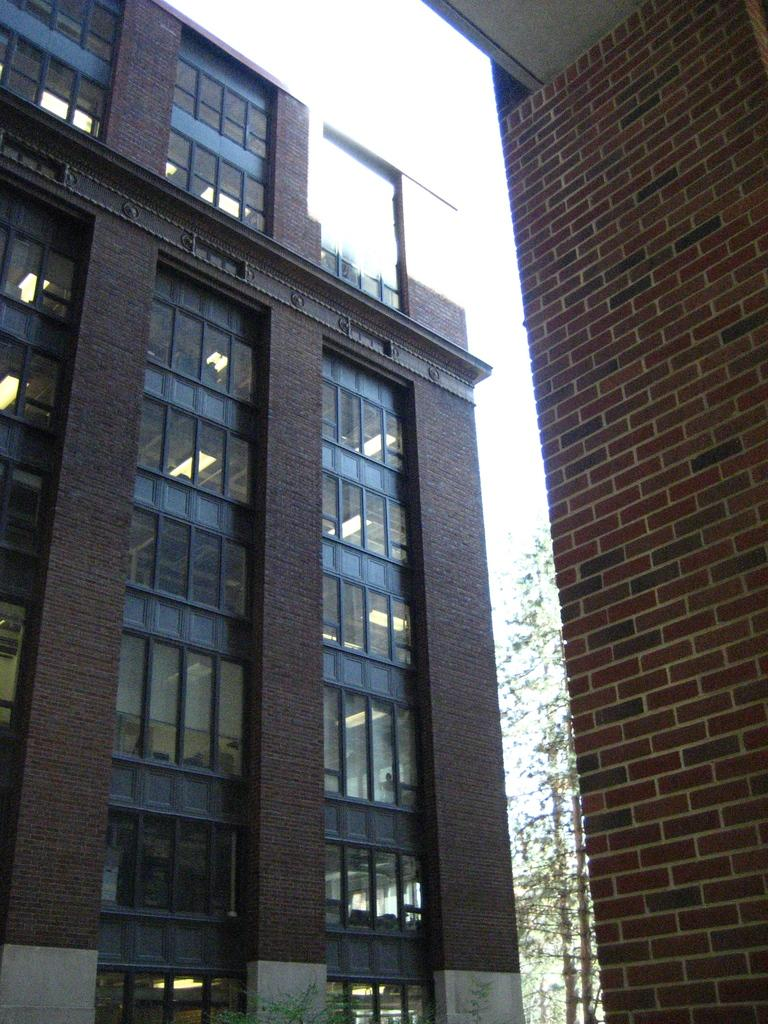What type of structures can be seen in the image? There are buildings in the image. What type of artificial light sources are visible in the image? There are electric lights in the image. What type of natural elements are present in the image? There are plants in the image. What is visible in the background of the image? The sky is visible in the image. What type of silk material is being used to connect the buildings in the image? There is no silk material or connection between the buildings in the image; they are separate structures. What type of office furniture can be seen in the image? There is no office furniture present in the image. 